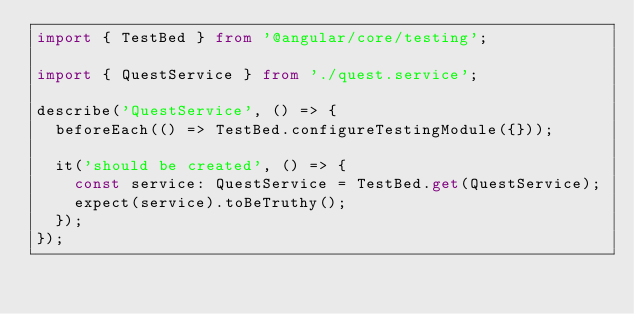Convert code to text. <code><loc_0><loc_0><loc_500><loc_500><_TypeScript_>import { TestBed } from '@angular/core/testing';

import { QuestService } from './quest.service';

describe('QuestService', () => {
  beforeEach(() => TestBed.configureTestingModule({}));

  it('should be created', () => {
    const service: QuestService = TestBed.get(QuestService);
    expect(service).toBeTruthy();
  });
});
</code> 